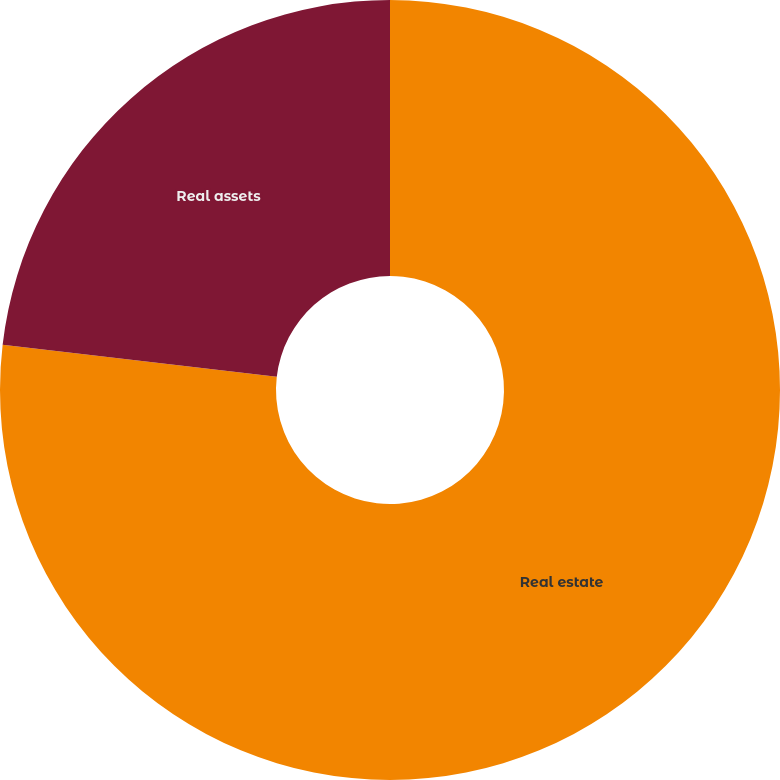Convert chart to OTSL. <chart><loc_0><loc_0><loc_500><loc_500><pie_chart><fcel>Real estate<fcel>Real assets<nl><fcel>76.85%<fcel>23.15%<nl></chart> 